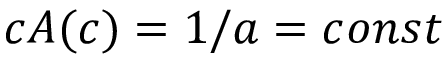<formula> <loc_0><loc_0><loc_500><loc_500>c A ( c ) = 1 / a = c o n s t</formula> 